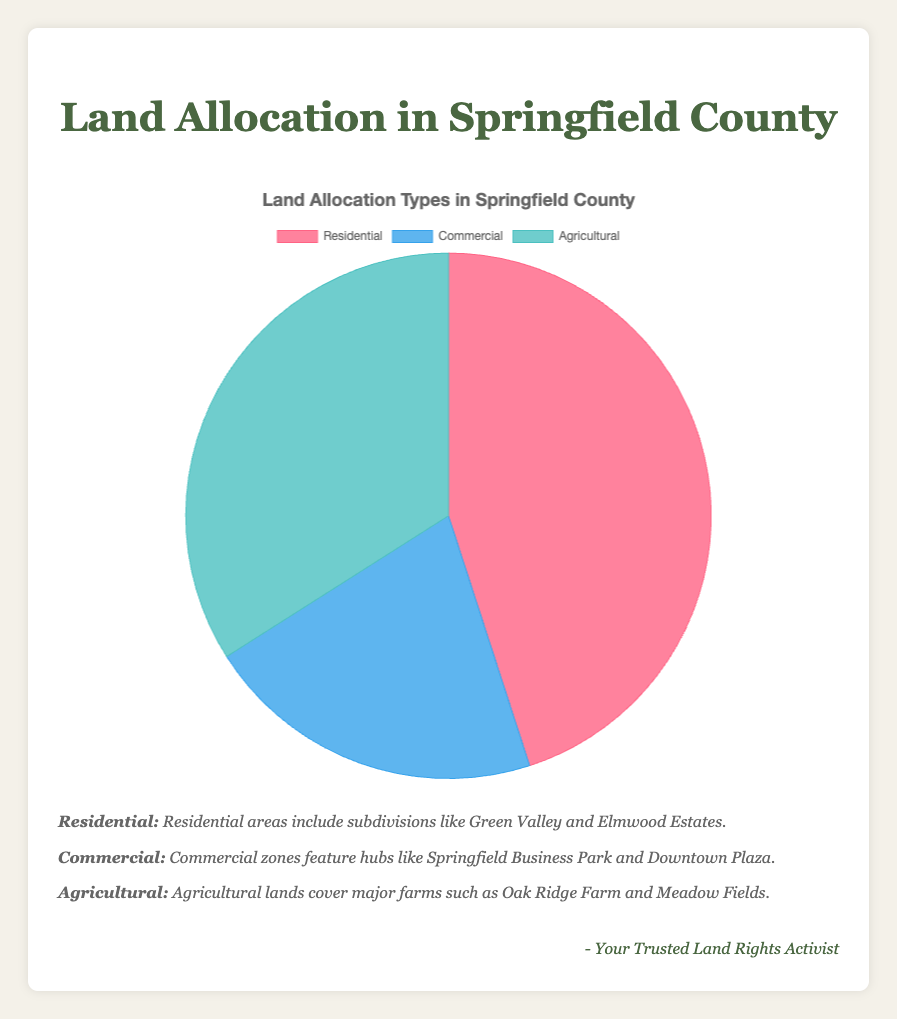What percentage of the land is allocated for residential purposes? The figure shows a pie chart where the residential land allocation is indicated by a segment labeled "Residential", which takes up 45% of the chart.
Answer: 45% How many more acres are allocated to residential land compared to commercial land? The chart indicates that residential land covers 15000 acres, while commercial land covers 7000 acres. The difference is 15000 - 7000 = 8000 acres.
Answer: 8000 acres Which type of land allocation has the lowest percentage of total land? The pie chart visually shows that the "Commercial" segment is the smallest, indicating it has the lowest percentage at 21%.
Answer: Commercial What is the total percentage of land allocated for non-agricultural purposes? The total percentage for non-agricultural purposes includes residential and commercial land. The sum is 45% (residential) + 21% (commercial) = 66%.
Answer: 66% By how many percentage points does residential land exceed agricultural land? The chart shows 45% for residential and 34% for agricultural land. The difference is 45% - 34% = 11 percentage points.
Answer: 11 percentage points If one wanted to develop an additional 1000 acres of commercial land, what would be the new total commercial land acreage and percentage allocation? The current commercial land is 7000 acres. Adding 1000 acres results in 7000 + 1000 = 8000 acres. The new total land allocation becomes 15000 (residential) + 11500 (agricultural) + 8000 (commercial) = 34500 acres. The new percentage for commercial land is (8000 / 34500) * 100 ≈ 23.2%.
Answer: 8000 acres, 23.2% Which color represents agricultural land on the pie chart? The pie chart uses different colors to represent different segments. The agricultural segment is in green.
Answer: Green Which type of land allocation covers the largest area in acres? The figure details that residential land encompasses 15000 acres, which is the largest acreage among the listed types.
Answer: Residential 